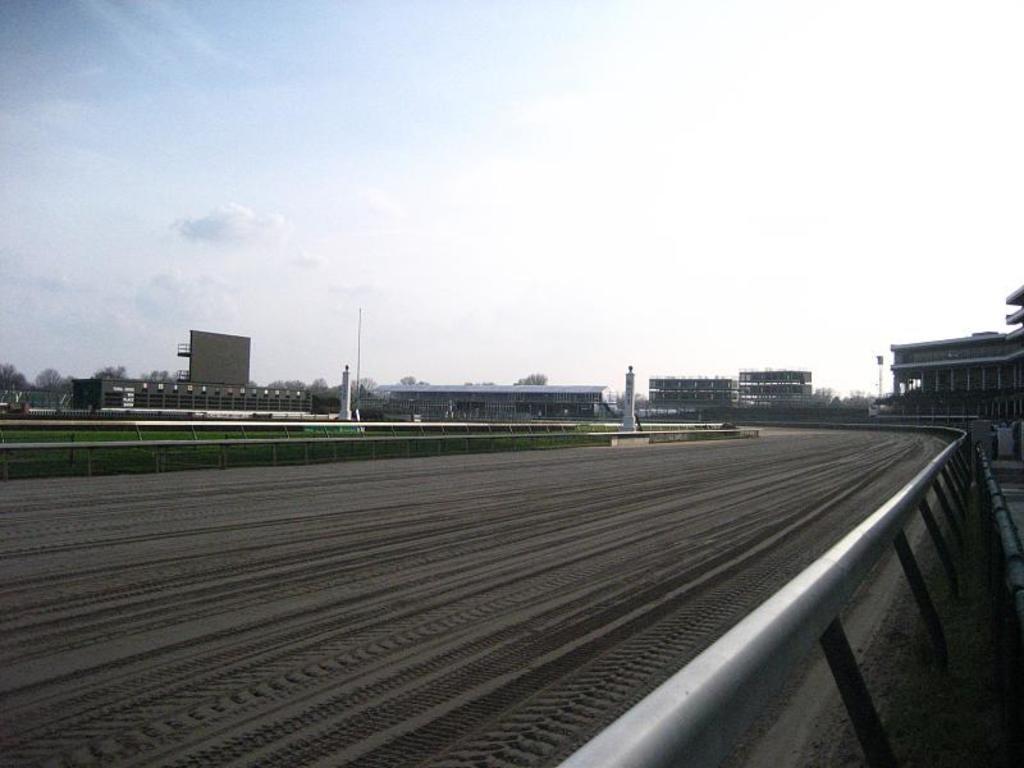Describe this image in one or two sentences. In this image there is the sky truncated towards the top of the image, there are buildings, there is a building truncated towards the right of the image, there is grass truncated towards the left of the image, there is a tree truncated towards the left of the image, there is a racing track truncated towards the bottom of the image, there is a fencing truncated towards the bottom of the image. 